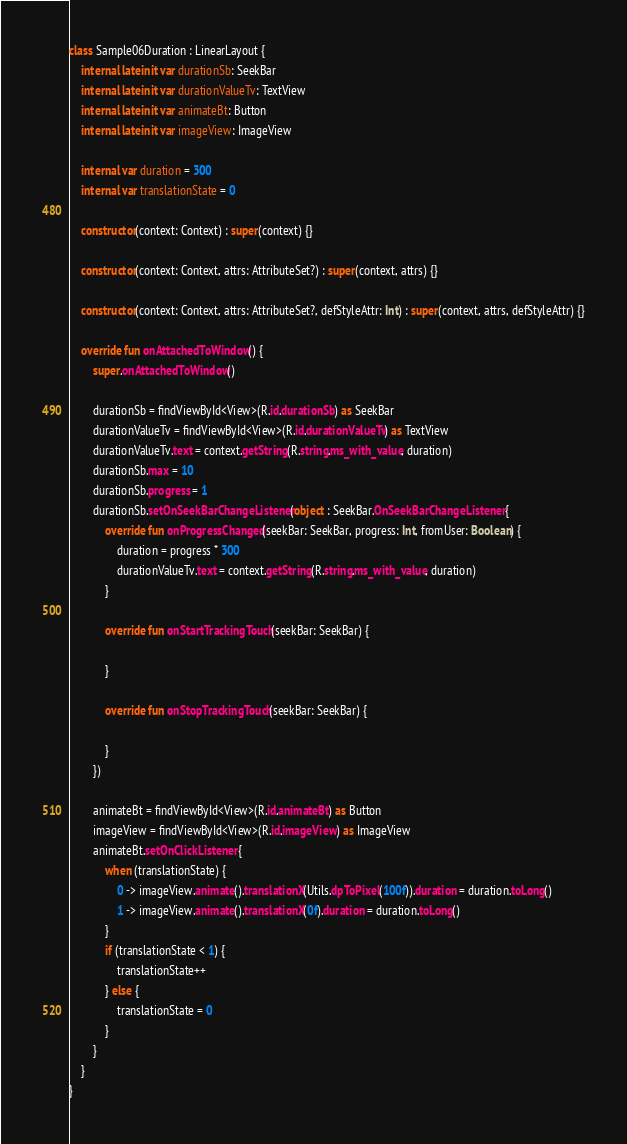<code> <loc_0><loc_0><loc_500><loc_500><_Kotlin_>class Sample06Duration : LinearLayout {
    internal lateinit var durationSb: SeekBar
    internal lateinit var durationValueTv: TextView
    internal lateinit var animateBt: Button
    internal lateinit var imageView: ImageView

    internal var duration = 300
    internal var translationState = 0

    constructor(context: Context) : super(context) {}

    constructor(context: Context, attrs: AttributeSet?) : super(context, attrs) {}

    constructor(context: Context, attrs: AttributeSet?, defStyleAttr: Int) : super(context, attrs, defStyleAttr) {}

    override fun onAttachedToWindow() {
        super.onAttachedToWindow()

        durationSb = findViewById<View>(R.id.durationSb) as SeekBar
        durationValueTv = findViewById<View>(R.id.durationValueTv) as TextView
        durationValueTv.text = context.getString(R.string.ms_with_value, duration)
        durationSb.max = 10
        durationSb.progress = 1
        durationSb.setOnSeekBarChangeListener(object : SeekBar.OnSeekBarChangeListener {
            override fun onProgressChanged(seekBar: SeekBar, progress: Int, fromUser: Boolean) {
                duration = progress * 300
                durationValueTv.text = context.getString(R.string.ms_with_value, duration)
            }

            override fun onStartTrackingTouch(seekBar: SeekBar) {

            }

            override fun onStopTrackingTouch(seekBar: SeekBar) {

            }
        })

        animateBt = findViewById<View>(R.id.animateBt) as Button
        imageView = findViewById<View>(R.id.imageView) as ImageView
        animateBt.setOnClickListener {
            when (translationState) {
                0 -> imageView.animate().translationX(Utils.dpToPixel(100f)).duration = duration.toLong()
                1 -> imageView.animate().translationX(0f).duration = duration.toLong()
            }
            if (translationState < 1) {
                translationState++
            } else {
                translationState = 0
            }
        }
    }
}
</code> 